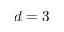<formula> <loc_0><loc_0><loc_500><loc_500>d = 3</formula> 